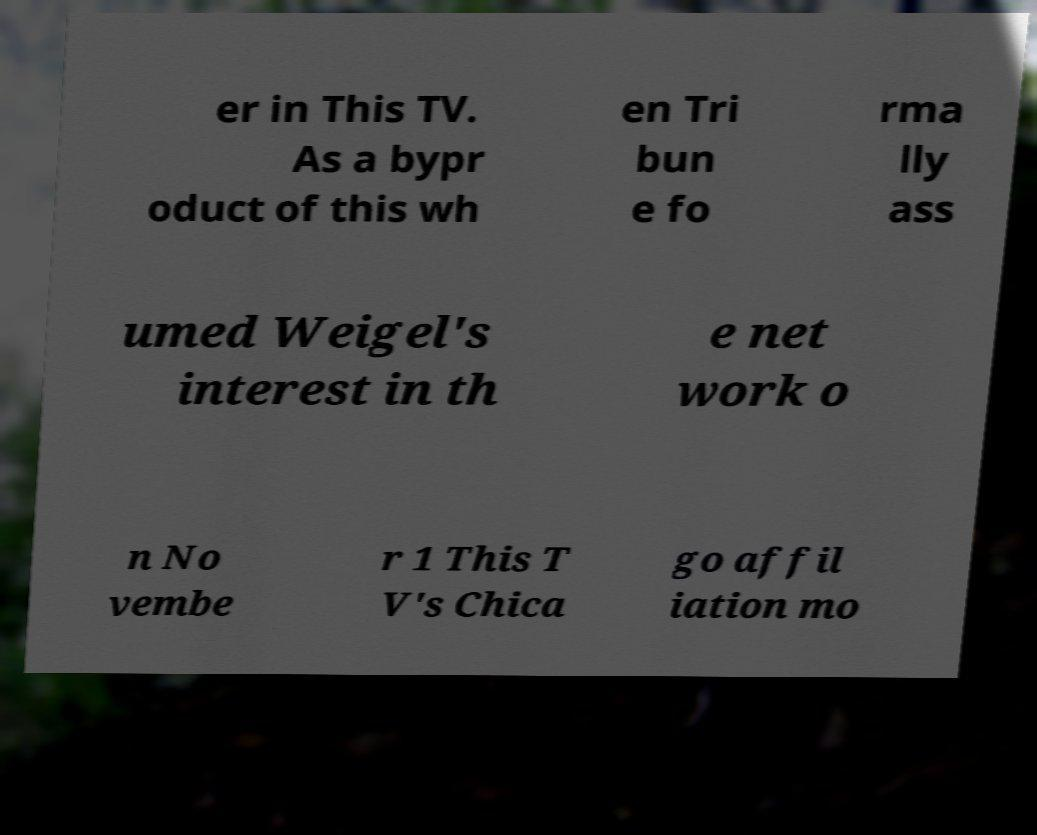Please identify and transcribe the text found in this image. er in This TV. As a bypr oduct of this wh en Tri bun e fo rma lly ass umed Weigel's interest in th e net work o n No vembe r 1 This T V's Chica go affil iation mo 